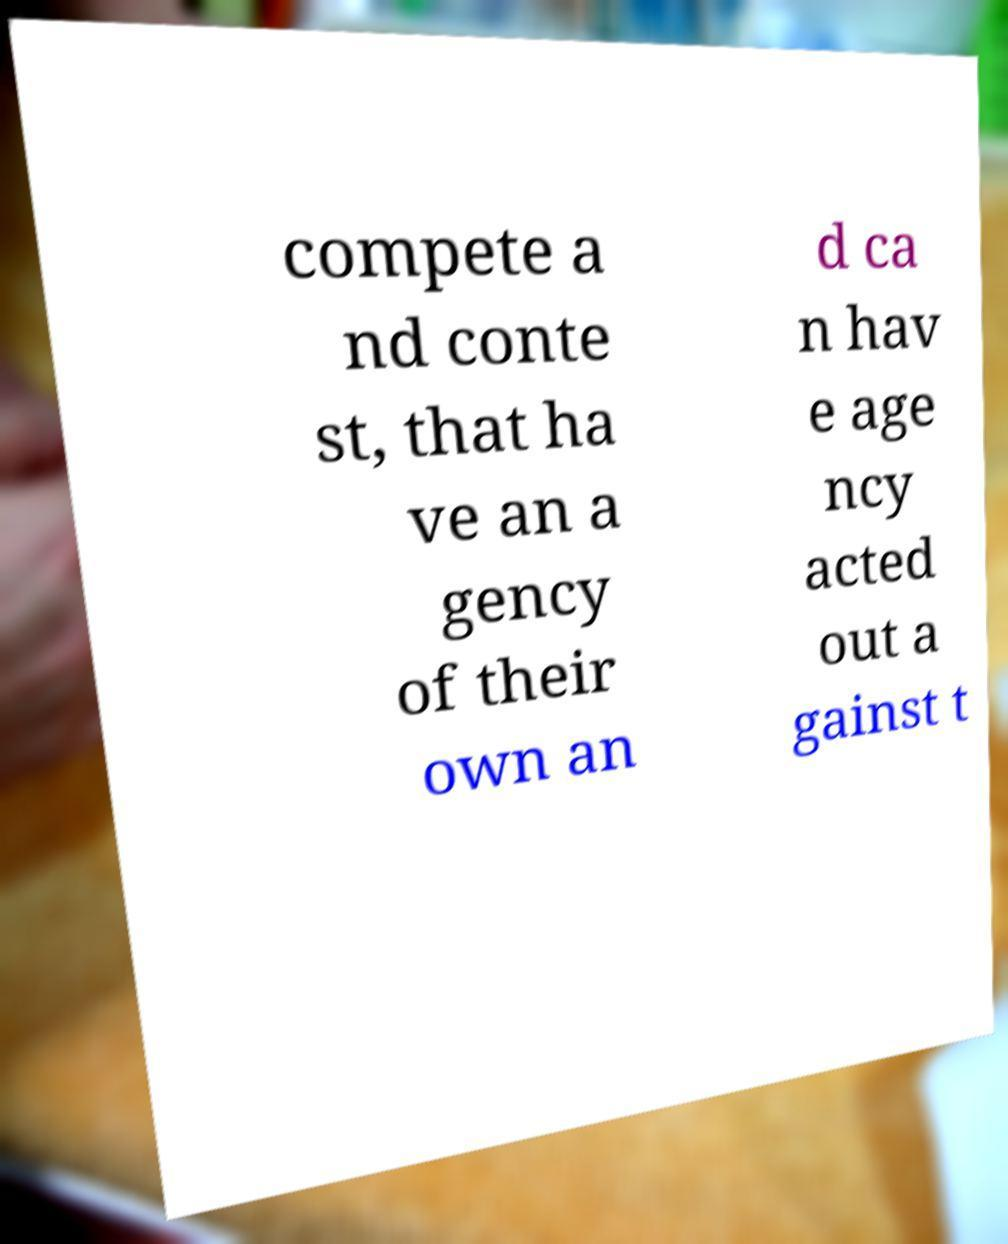Can you read and provide the text displayed in the image?This photo seems to have some interesting text. Can you extract and type it out for me? compete a nd conte st, that ha ve an a gency of their own an d ca n hav e age ncy acted out a gainst t 